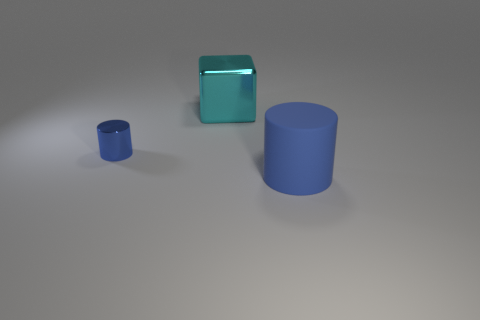What is the size of the blue cylinder that is left of the big object to the right of the cyan shiny object?
Provide a short and direct response. Small. There is another small object that is the same shape as the matte thing; what is its color?
Your answer should be compact. Blue. Is the size of the blue metallic object the same as the cyan metallic cube?
Provide a succinct answer. No. Is the number of big blue rubber things in front of the big blue cylinder the same as the number of blue metallic things?
Your response must be concise. No. There is a cylinder that is on the left side of the big cylinder; are there any tiny blue objects that are in front of it?
Provide a short and direct response. No. There is a blue object on the right side of the blue object left of the blue cylinder that is on the right side of the large cube; what is its size?
Provide a short and direct response. Large. Is the number of cyan cubes the same as the number of shiny things?
Ensure brevity in your answer.  No. There is a blue cylinder that is to the right of the tiny object in front of the cyan cube; what is it made of?
Provide a short and direct response. Rubber. Is there a tiny metal object of the same shape as the matte object?
Provide a short and direct response. Yes. The blue rubber object has what shape?
Ensure brevity in your answer.  Cylinder. 